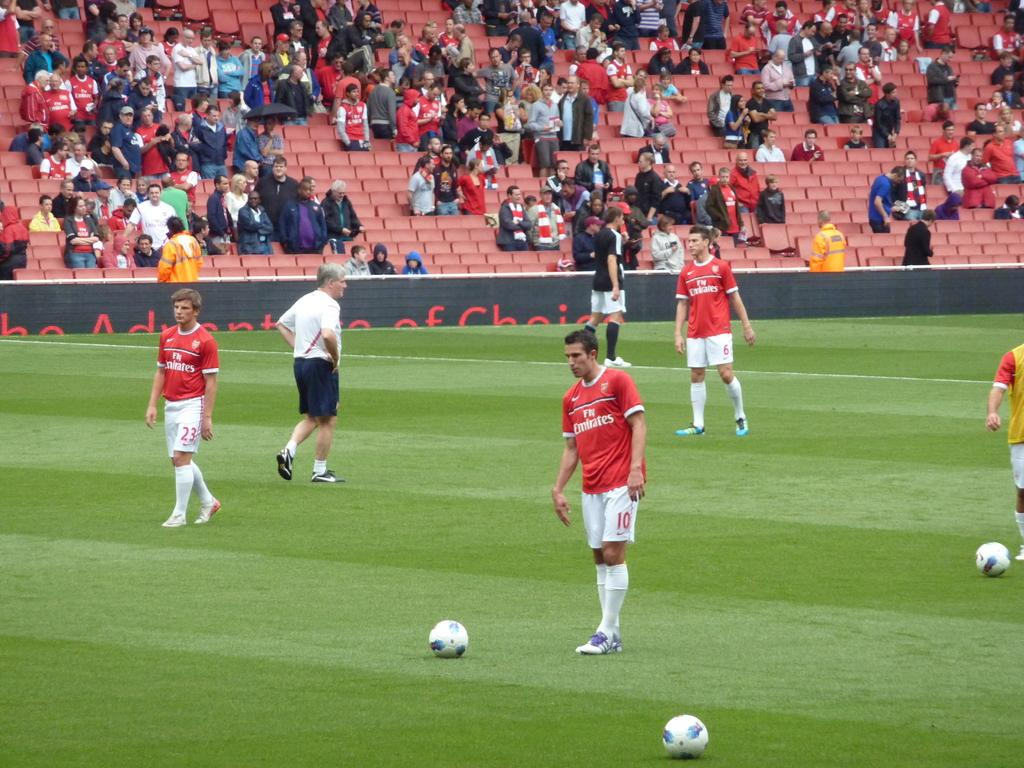<image>
Offer a succinct explanation of the picture presented. A group of men are on a soccer field and have the word emirates on their jerseys. 